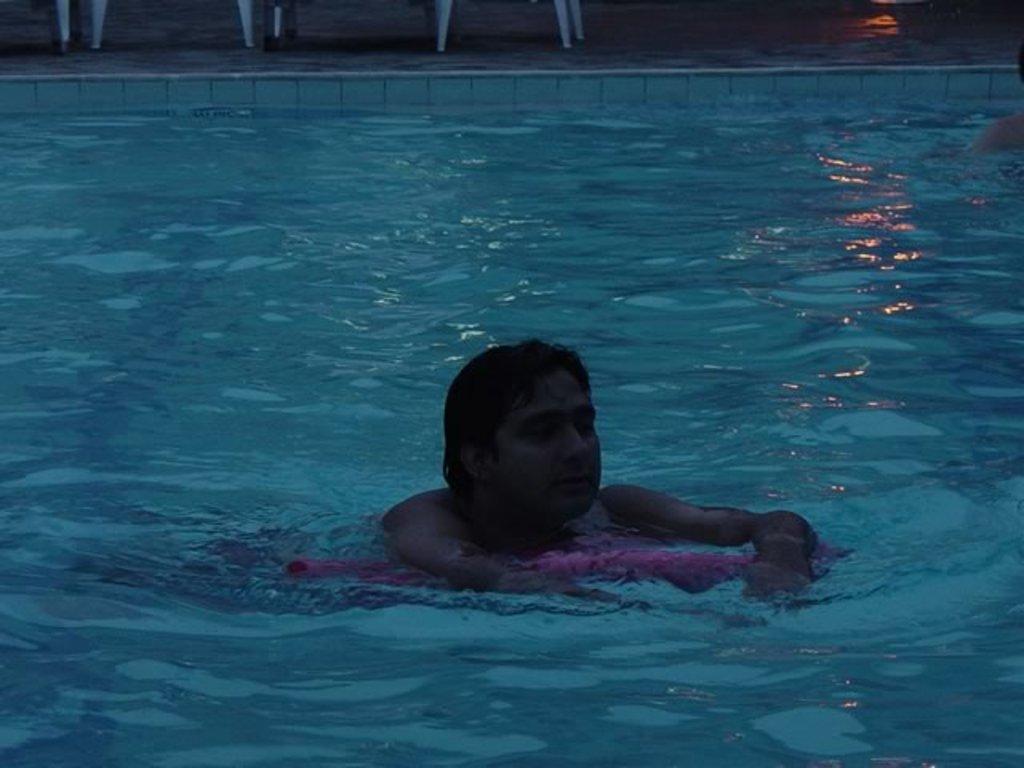Describe this image in one or two sentences. In this image there is a person swimming in the swimming pool. 